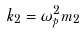<formula> <loc_0><loc_0><loc_500><loc_500>k _ { 2 } = \omega _ { p } ^ { 2 } m _ { 2 }</formula> 